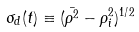Convert formula to latex. <formula><loc_0><loc_0><loc_500><loc_500>\sigma _ { d } ( t ) \equiv ( \bar { \rho ^ { 2 } } - \rho _ { i } ^ { 2 } ) ^ { 1 / 2 }</formula> 